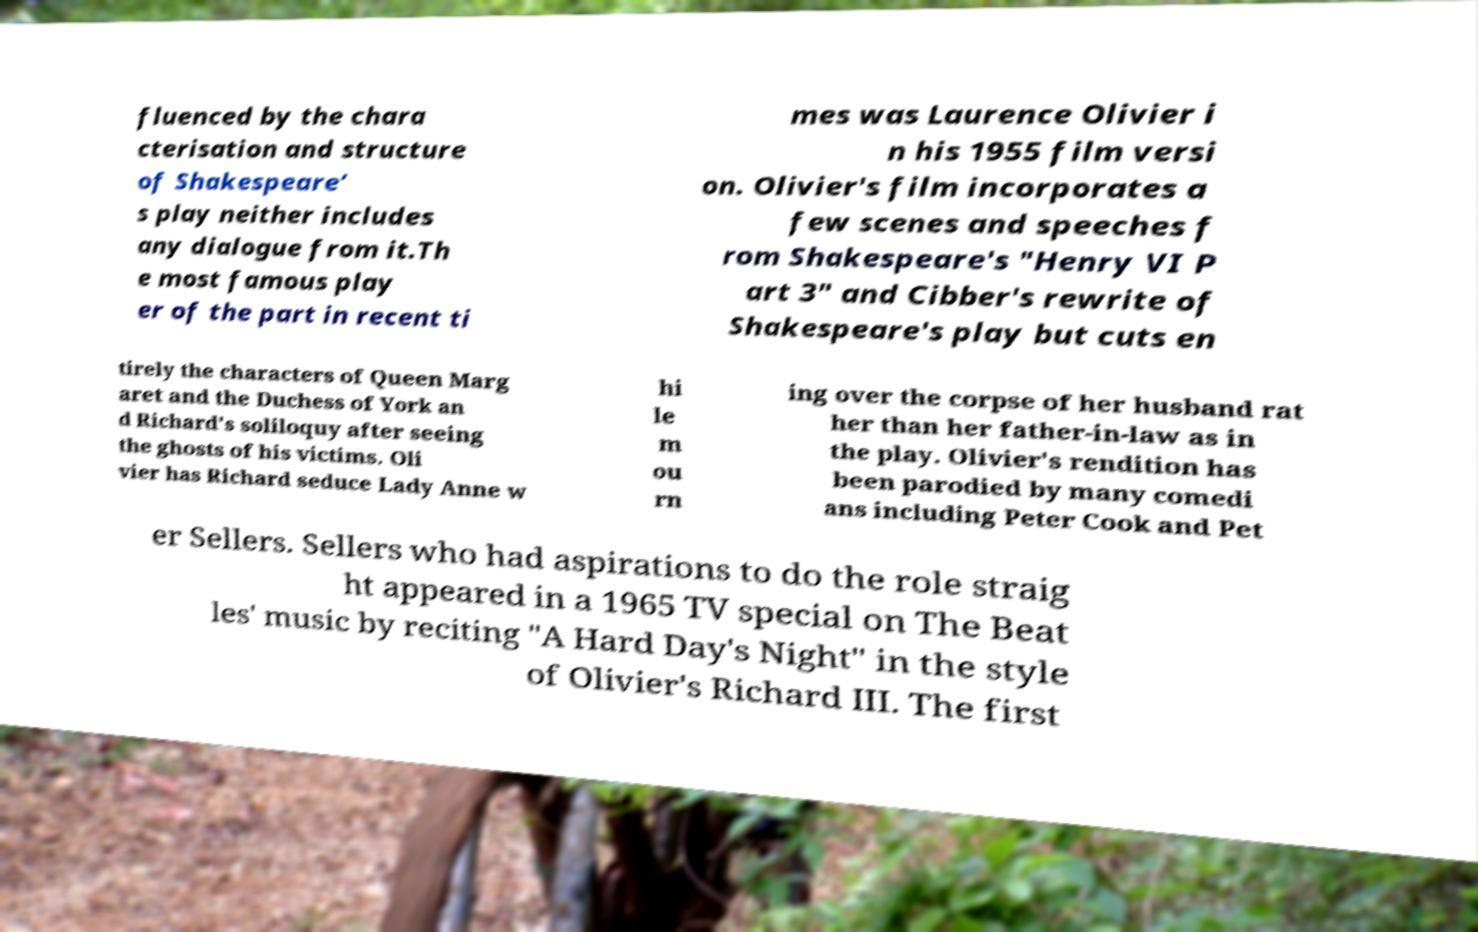Can you accurately transcribe the text from the provided image for me? fluenced by the chara cterisation and structure of Shakespeare’ s play neither includes any dialogue from it.Th e most famous play er of the part in recent ti mes was Laurence Olivier i n his 1955 film versi on. Olivier's film incorporates a few scenes and speeches f rom Shakespeare's "Henry VI P art 3" and Cibber's rewrite of Shakespeare's play but cuts en tirely the characters of Queen Marg aret and the Duchess of York an d Richard's soliloquy after seeing the ghosts of his victims. Oli vier has Richard seduce Lady Anne w hi le m ou rn ing over the corpse of her husband rat her than her father-in-law as in the play. Olivier's rendition has been parodied by many comedi ans including Peter Cook and Pet er Sellers. Sellers who had aspirations to do the role straig ht appeared in a 1965 TV special on The Beat les' music by reciting "A Hard Day's Night" in the style of Olivier's Richard III. The first 